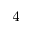<formula> <loc_0><loc_0><loc_500><loc_500>^ { 4 }</formula> 